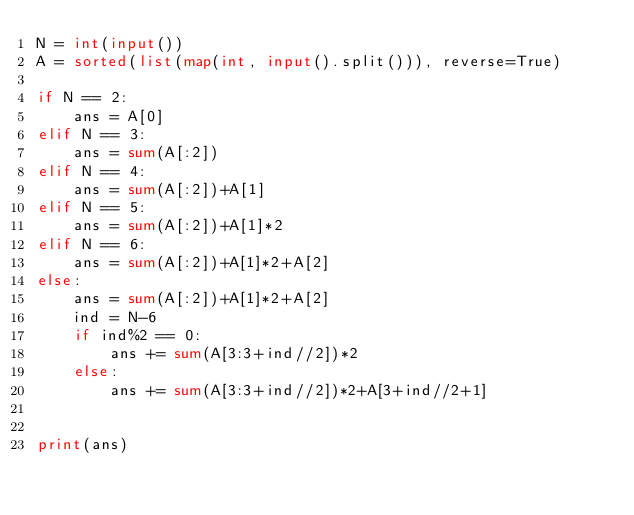<code> <loc_0><loc_0><loc_500><loc_500><_Python_>N = int(input())
A = sorted(list(map(int, input().split())), reverse=True)

if N == 2:
    ans = A[0]
elif N == 3:
    ans = sum(A[:2])
elif N == 4:
    ans = sum(A[:2])+A[1]
elif N == 5:
    ans = sum(A[:2])+A[1]*2
elif N == 6:
    ans = sum(A[:2])+A[1]*2+A[2]
else:
    ans = sum(A[:2])+A[1]*2+A[2]
    ind = N-6
    if ind%2 == 0:
        ans += sum(A[3:3+ind//2])*2
    else:
        ans += sum(A[3:3+ind//2])*2+A[3+ind//2+1]


print(ans)</code> 